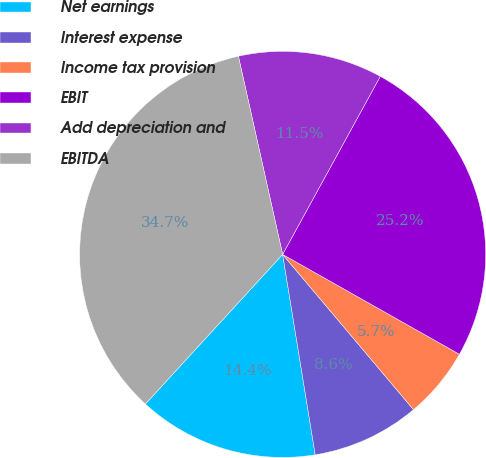Convert chart to OTSL. <chart><loc_0><loc_0><loc_500><loc_500><pie_chart><fcel>Net earnings<fcel>Interest expense<fcel>Income tax provision<fcel>EBIT<fcel>Add depreciation and<fcel>EBITDA<nl><fcel>14.38%<fcel>8.58%<fcel>5.67%<fcel>25.2%<fcel>11.48%<fcel>34.69%<nl></chart> 